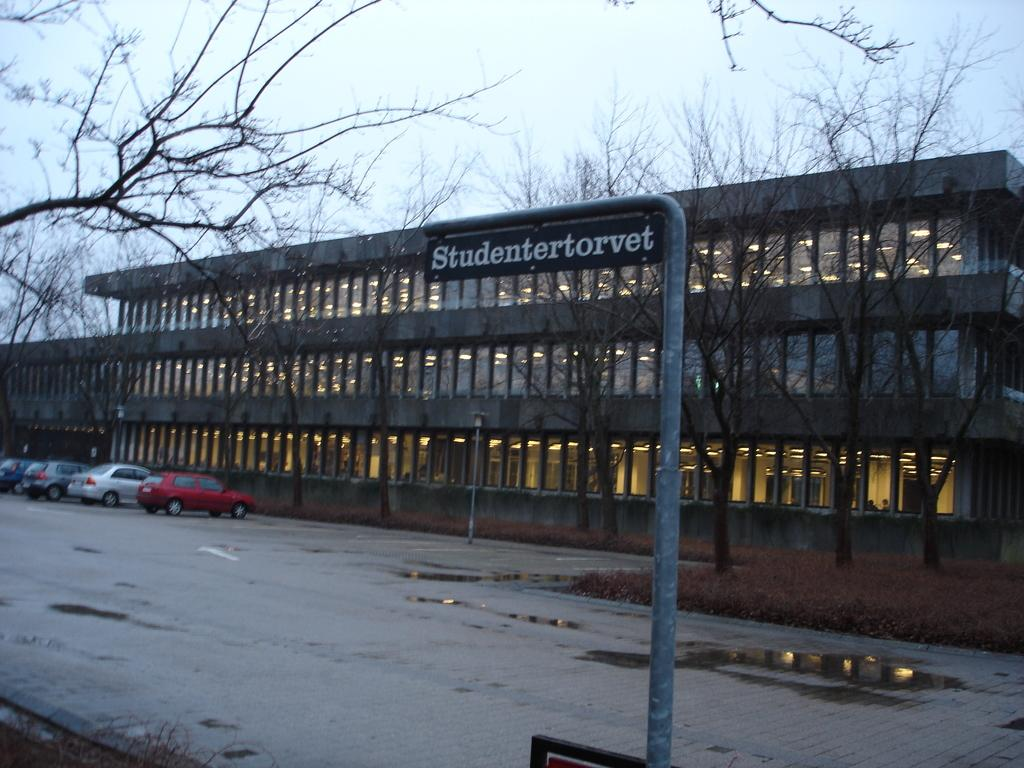What type of structure is present in the image? There is a building in the image. What feature can be seen on the building? The building has windows. What can be seen illuminated in the image? There are lights visible in the image. What type of transportation is present in the image? There are vehicles in the image. What type of natural element is present in the image? There are trees in the image. What type of vertical structure is present in the image? There is a pole in the image. What type of signage is present in the image? There is a board with text in the image. Can you see any blood dripping from the pole in the image? There is no blood or dripping present in the image. Are there any people in the image crying? There are no people or crying depicted in the image. 